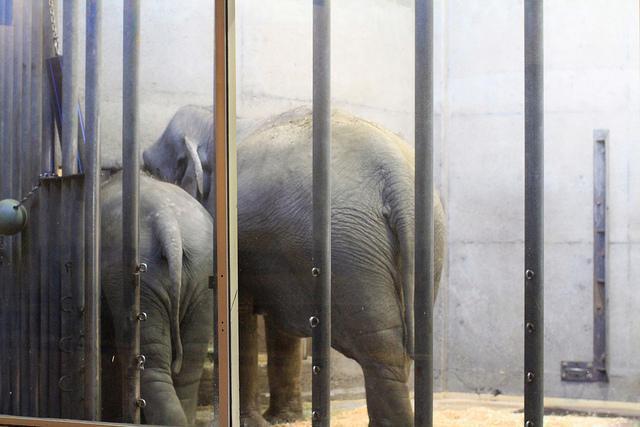How many elephants are there?
Give a very brief answer. 2. How many people are in the picture?
Give a very brief answer. 0. 